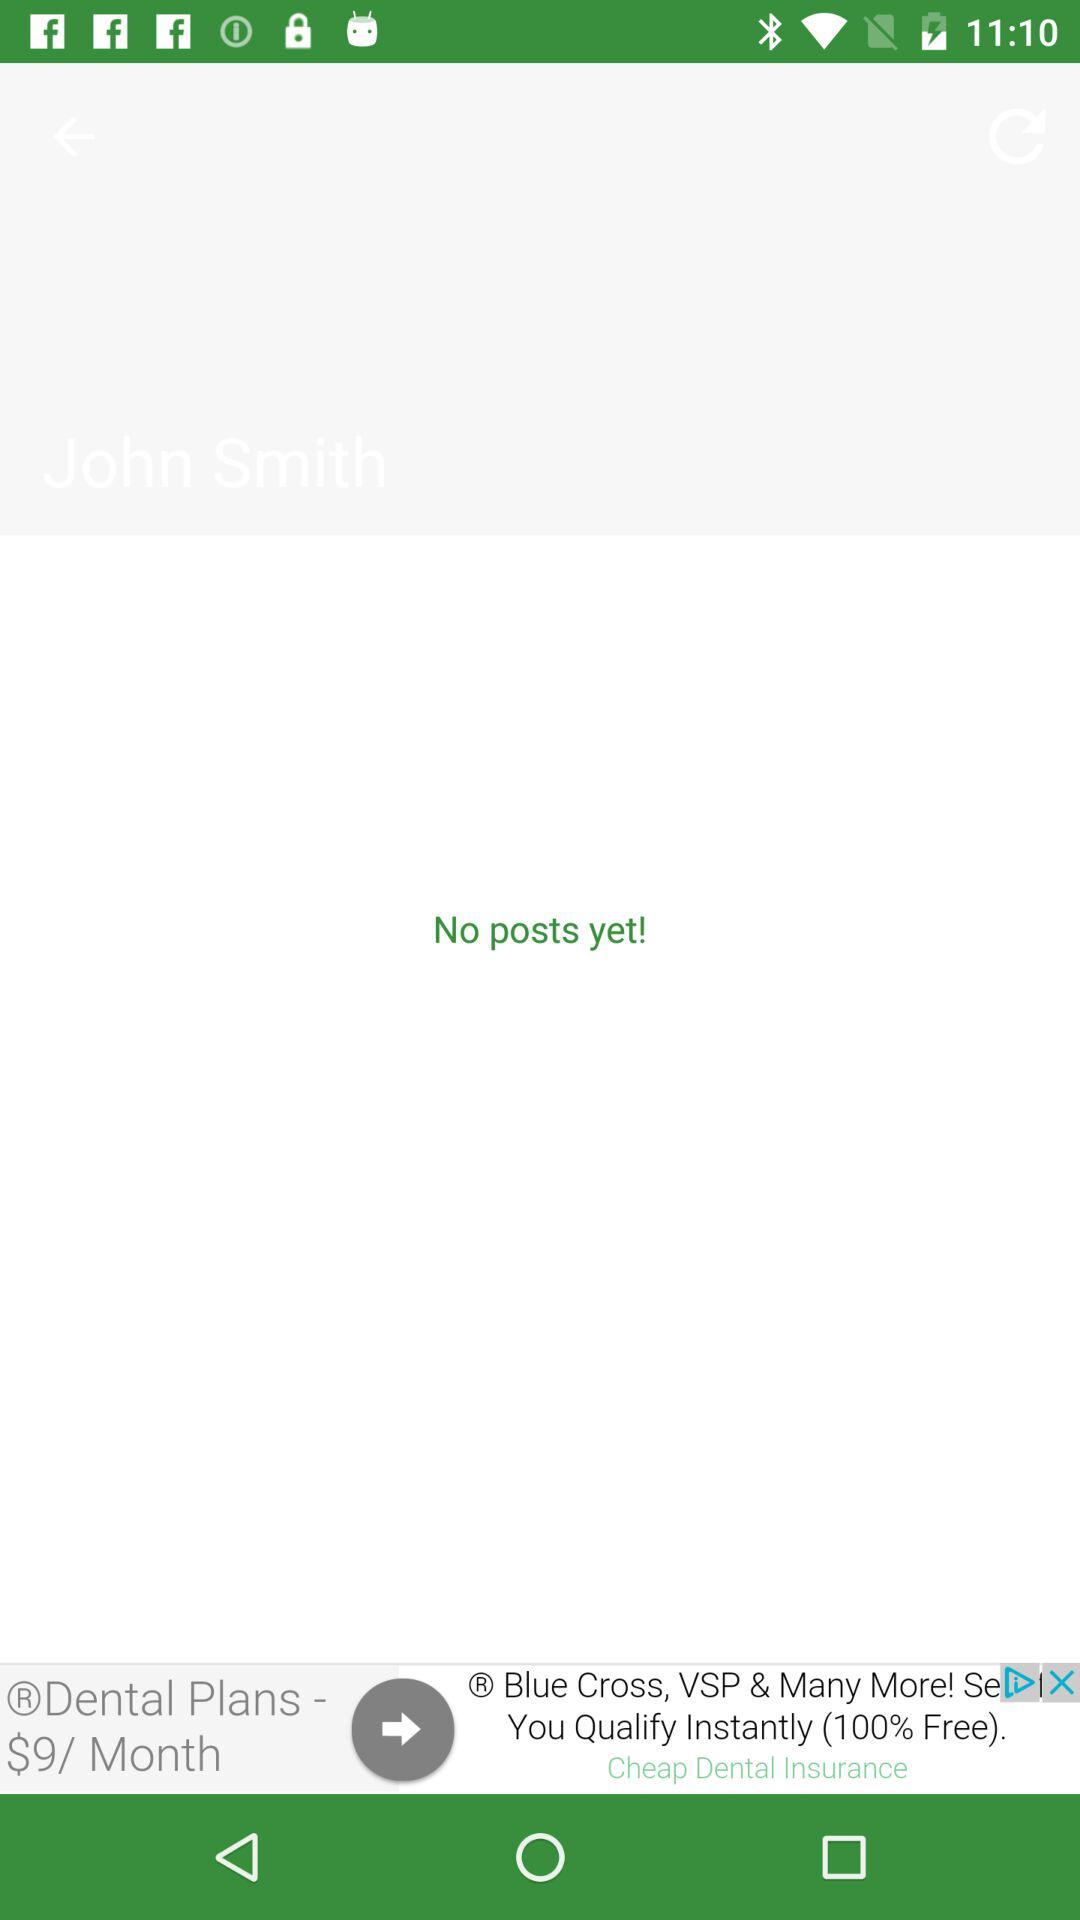Is there any post? There is no post. 